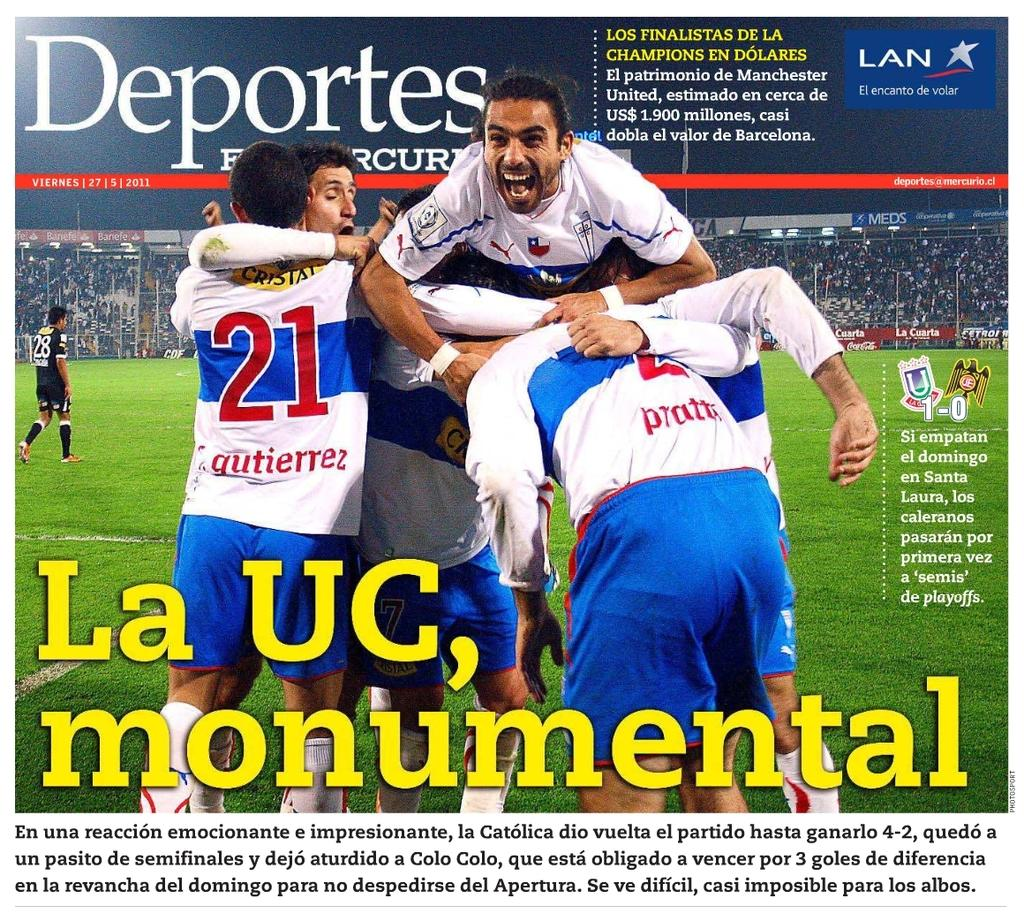Provide a one-sentence caption for the provided image. La UC, monumental is the lead story of the Deportes publication. 